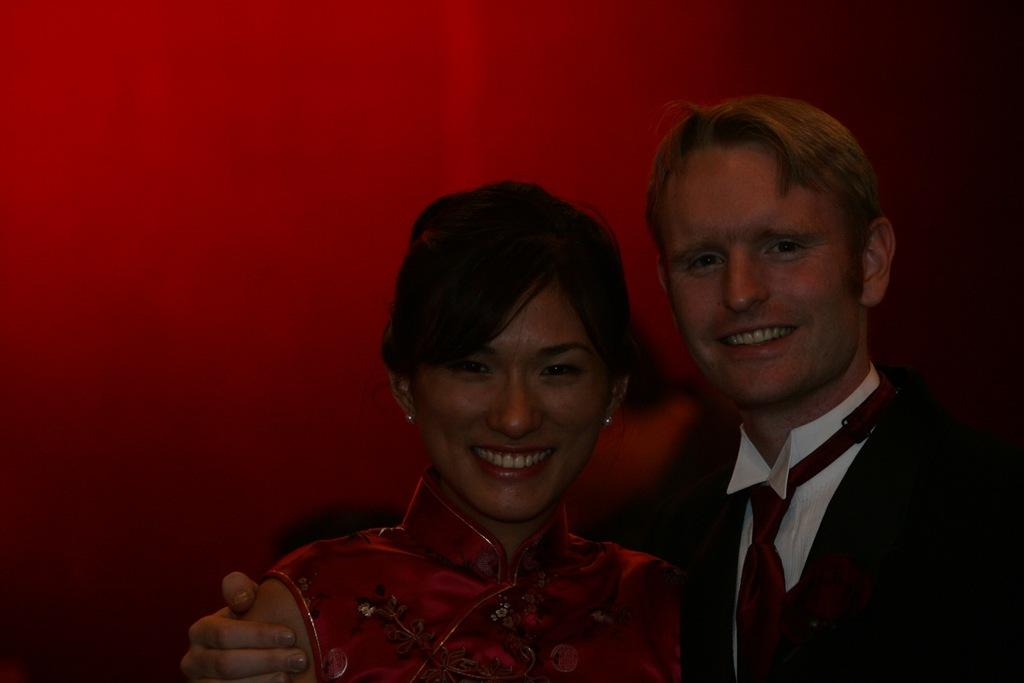Who are the main subjects in the foreground of the picture? There is a couple in the foreground of the picture. What are the couple doing in the image? The couple is standing and posing to the camera. What can be seen in the background of the picture? There is a red color wall in the background of the picture. How does the couple's digestion affect the image? There is no information about the couple's digestion in the image, so it cannot be determined how it affects the image. 